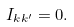<formula> <loc_0><loc_0><loc_500><loc_500>I _ { k k ^ { \prime } } = 0 .</formula> 